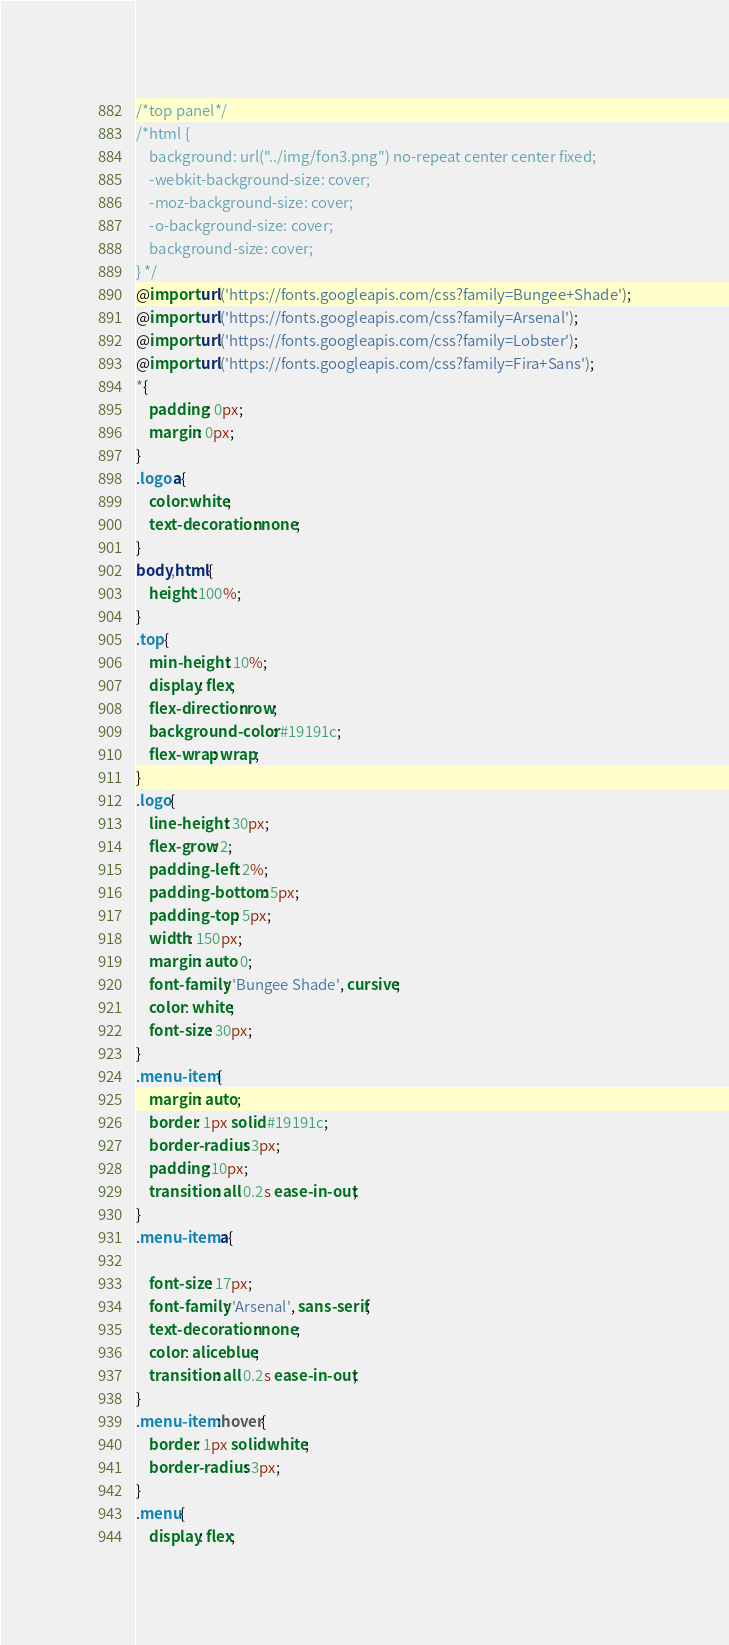Convert code to text. <code><loc_0><loc_0><loc_500><loc_500><_CSS_>/*top panel*/
/*html {
    background: url("../img/fon3.png") no-repeat center center fixed;
    -webkit-background-size: cover;
    -moz-background-size: cover;
    -o-background-size: cover;
    background-size: cover;
} */
@import url('https://fonts.googleapis.com/css?family=Bungee+Shade');
@import url('https://fonts.googleapis.com/css?family=Arsenal');
@import url('https://fonts.googleapis.com/css?family=Lobster');
@import url('https://fonts.googleapis.com/css?family=Fira+Sans');
*{
    padding: 0px;
    margin: 0px;
}
.logo a{
    color:white;
    text-decoration: none;
}
body,html{
    height:100%;
}
.top{
    min-height: 10%;
    display: flex;
    flex-direction: row;
    background-color: #19191c;
    flex-wrap: wrap;
}
.logo{
    line-height: 30px;
    flex-grow: 2;
    padding-left: 2%;
    padding-bottom: 5px;
    padding-top: 5px;
    width: 150px;
    margin: auto 0;
    font-family: 'Bungee Shade', cursive;
    color: white;
    font-size: 30px;
}
.menu-item{
    margin: auto;
    border: 1px solid #19191c;
    border-radius: 3px;
    padding:10px;
    transition: all 0.2s ease-in-out;
}
.menu-item a{

    font-size: 17px;
    font-family: 'Arsenal', sans-serif;
    text-decoration: none;
    color: aliceblue;
    transition: all 0.2s ease-in-out;
}
.menu-item:hover{
    border: 1px solid white;
    border-radius: 3px;
}
.menu{
    display: flex;</code> 